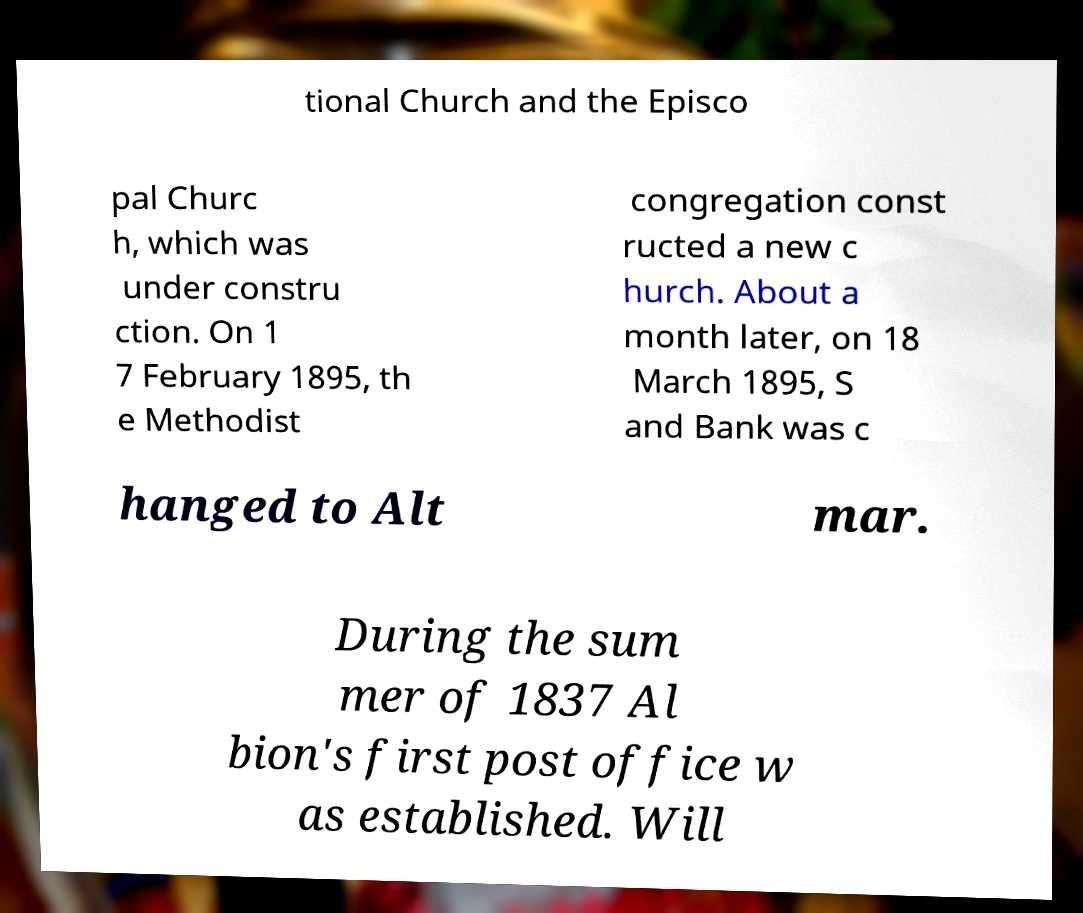There's text embedded in this image that I need extracted. Can you transcribe it verbatim? tional Church and the Episco pal Churc h, which was under constru ction. On 1 7 February 1895, th e Methodist congregation const ructed a new c hurch. About a month later, on 18 March 1895, S and Bank was c hanged to Alt mar. During the sum mer of 1837 Al bion's first post office w as established. Will 